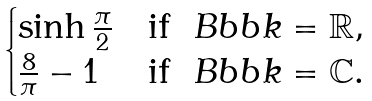<formula> <loc_0><loc_0><loc_500><loc_500>\begin{cases} \sinh \frac { \pi } { 2 } & \text {if } \ B b b k = \mathbb { R } , \\ \frac { 8 } { \pi } - 1 & \text {if } \ B b b k = \mathbb { C } . \end{cases}</formula> 